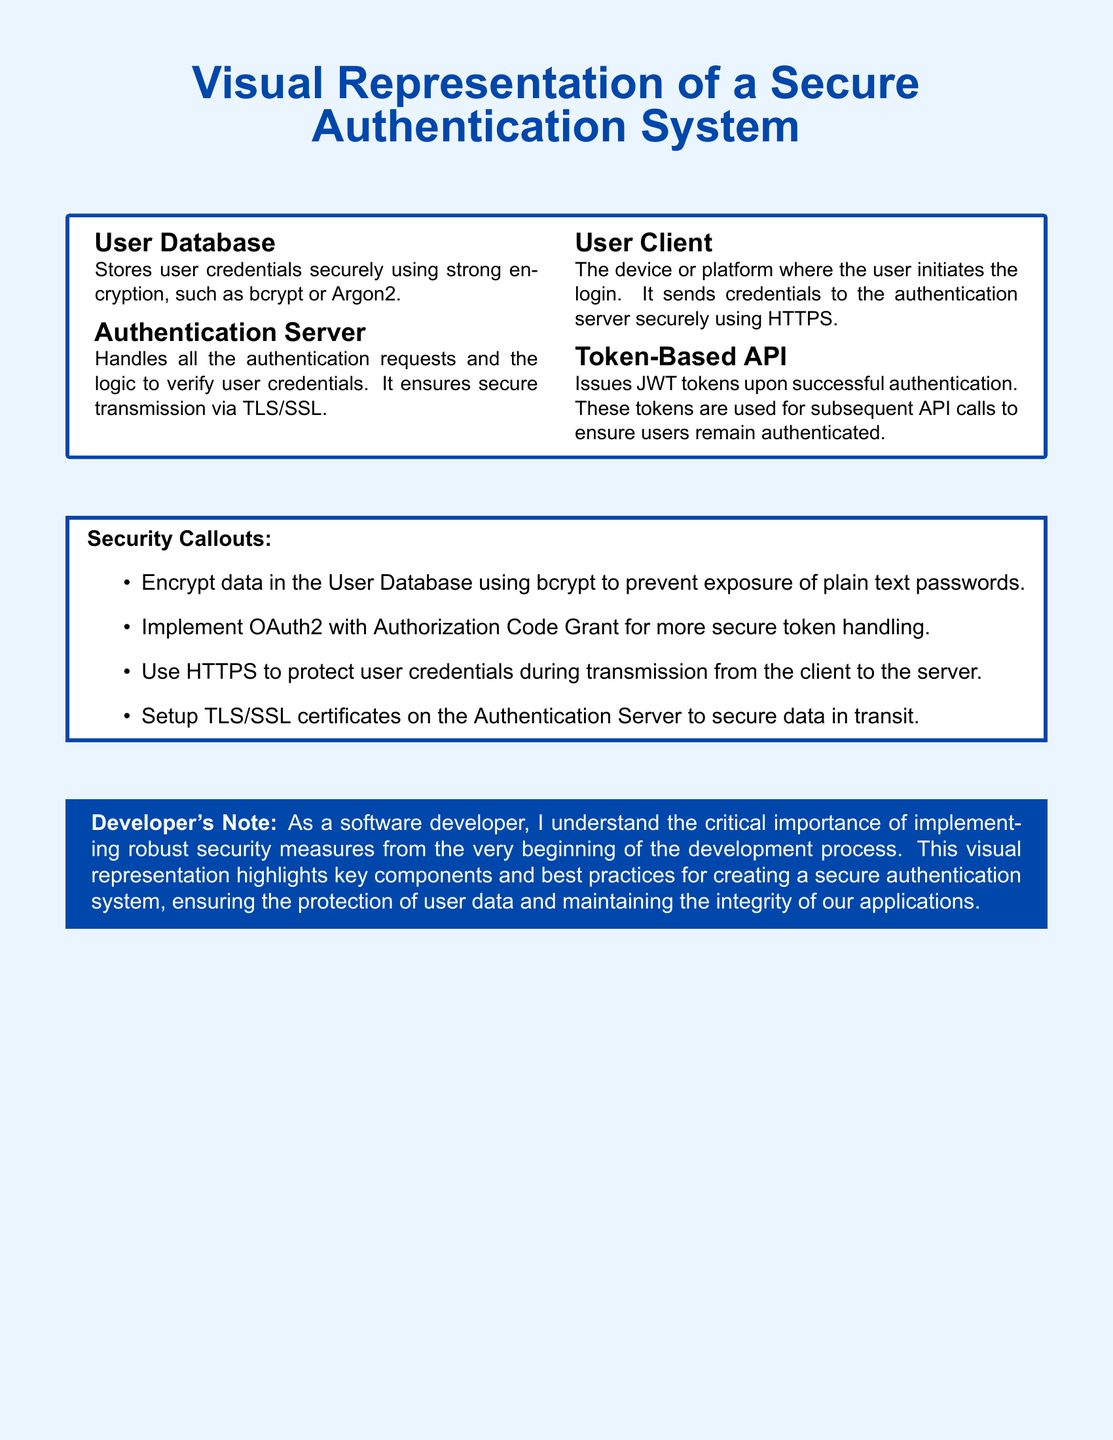What is stored in the User Database? The User Database stores user credentials securely using strong encryption like bcrypt or Argon2.
Answer: User credentials What does the Authentication Server handle? The Authentication Server handles authentication requests and verifies user credentials, ensuring secure transmission via TLS/SSL.
Answer: Authentication requests What protocol is used for secure transmission from User Client to the server? The User Client sends credentials to the authentication server securely using HTTPS.
Answer: HTTPS What does the Token-Based API issue upon successful authentication? The Token-Based API issues JWT tokens that are used for subsequent API calls to ensure users remain authenticated.
Answer: JWT tokens Which encryption method is recommended for the User Database? The recommended encryption method for the User Database is bcrypt.
Answer: bcrypt What type of grant is suggested for secure token handling? The document suggests implementing OAuth2 with Authorization Code Grant for more secure token handling.
Answer: Authorization Code Grant How many main components are highlighted in the visual representation? The visual representation includes four main components: User Database, Authentication Server, User Client, and Token-Based API.
Answer: Four What is the background color of the document? The background color of the document is light blue.
Answer: Light blue What does the Developer's Note stress as critical? The Developer's Note stresses the critical importance of implementing robust security measures from the beginning of the development process.
Answer: Robust security measures 